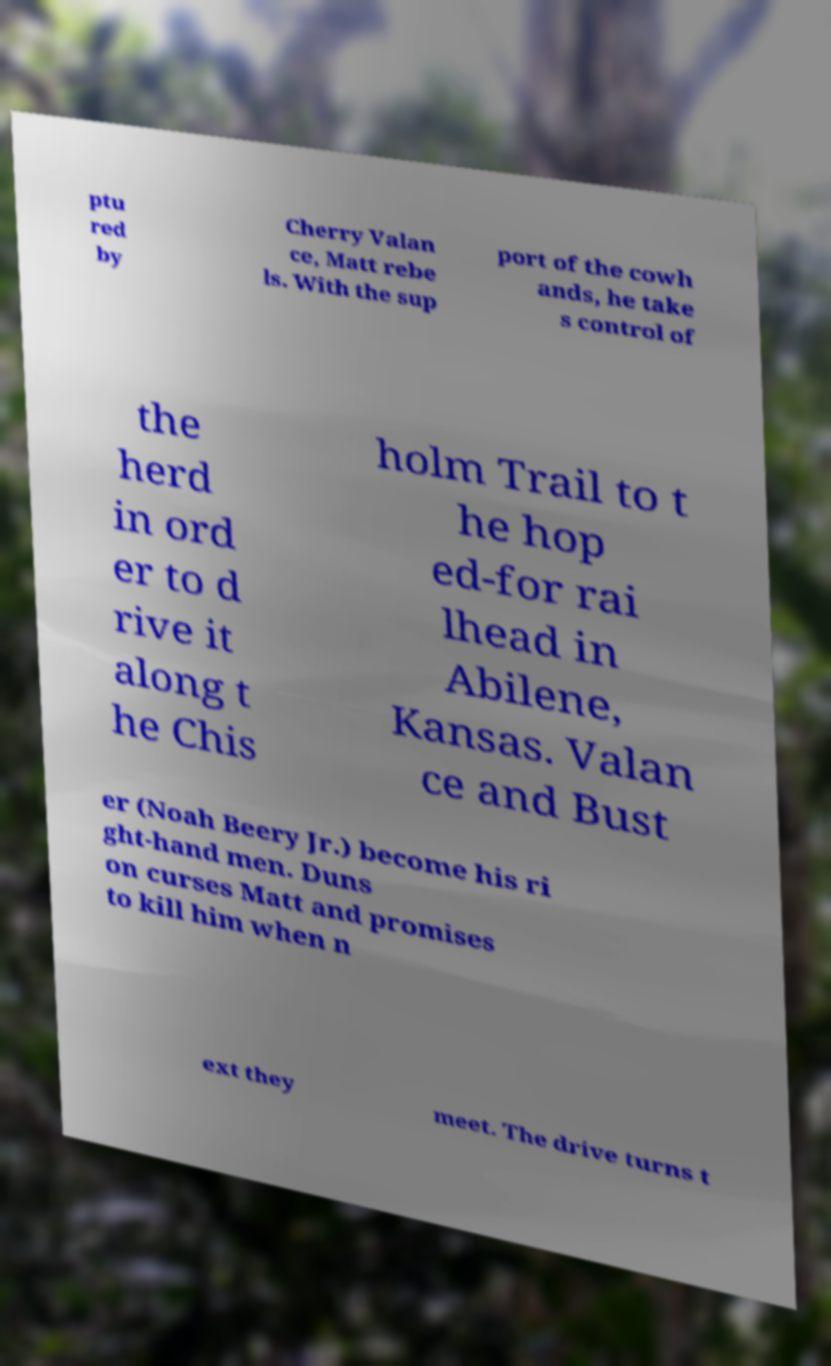I need the written content from this picture converted into text. Can you do that? ptu red by Cherry Valan ce, Matt rebe ls. With the sup port of the cowh ands, he take s control of the herd in ord er to d rive it along t he Chis holm Trail to t he hop ed-for rai lhead in Abilene, Kansas. Valan ce and Bust er (Noah Beery Jr.) become his ri ght-hand men. Duns on curses Matt and promises to kill him when n ext they meet. The drive turns t 